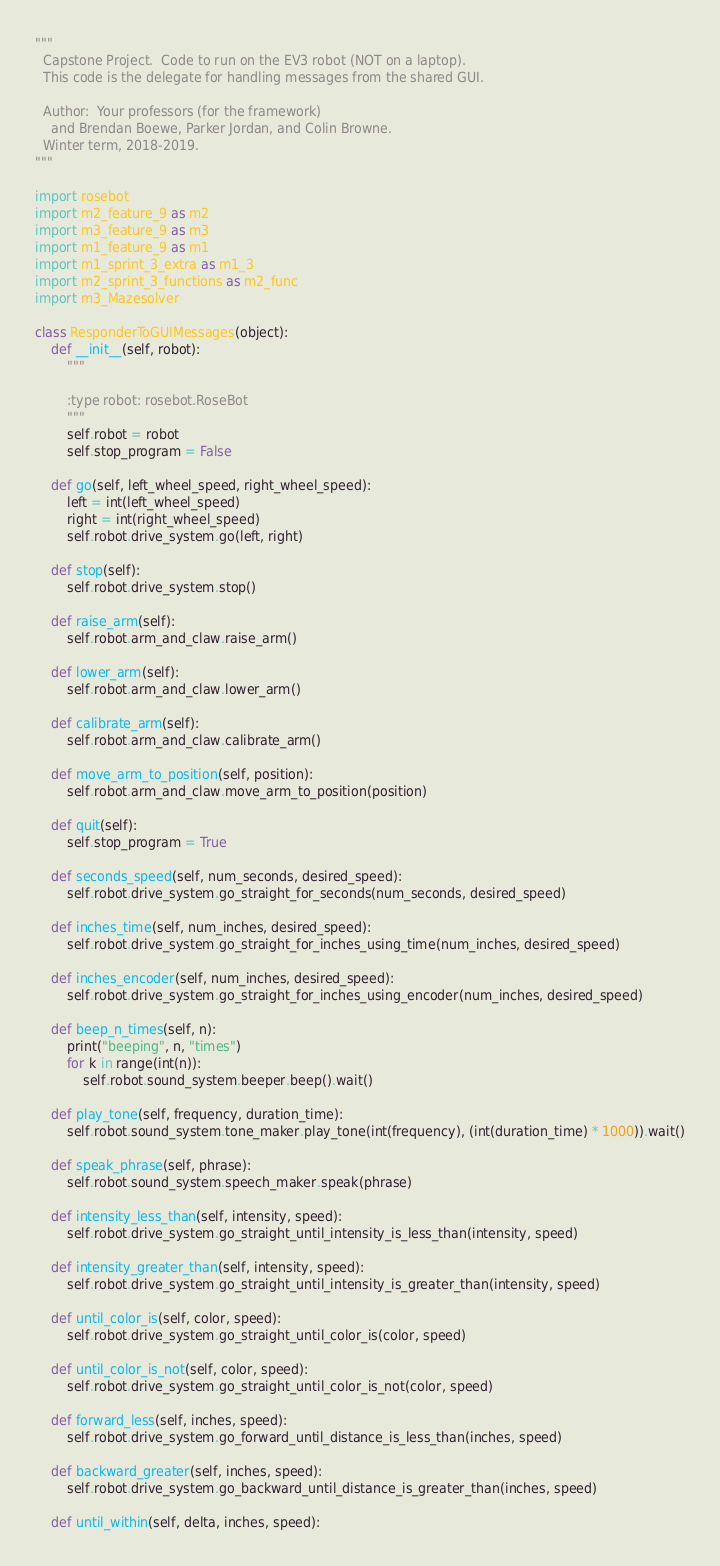Convert code to text. <code><loc_0><loc_0><loc_500><loc_500><_Python_>"""
  Capstone Project.  Code to run on the EV3 robot (NOT on a laptop).
  This code is the delegate for handling messages from the shared GUI.

  Author:  Your professors (for the framework)
    and Brendan Boewe, Parker Jordan, and Colin Browne.
  Winter term, 2018-2019.
"""

import rosebot
import m2_feature_9 as m2
import m3_feature_9 as m3
import m1_feature_9 as m1
import m1_sprint_3_extra as m1_3
import m2_sprint_3_functions as m2_func
import m3_Mazesolver

class ResponderToGUIMessages(object):
    def __init__(self, robot):
        """

        :type robot: rosebot.RoseBot
        """
        self.robot = robot
        self.stop_program = False

    def go(self, left_wheel_speed, right_wheel_speed):
        left = int(left_wheel_speed)
        right = int(right_wheel_speed)
        self.robot.drive_system.go(left, right)

    def stop(self):
        self.robot.drive_system.stop()

    def raise_arm(self):
        self.robot.arm_and_claw.raise_arm()

    def lower_arm(self):
        self.robot.arm_and_claw.lower_arm()

    def calibrate_arm(self):
        self.robot.arm_and_claw.calibrate_arm()

    def move_arm_to_position(self, position):
        self.robot.arm_and_claw.move_arm_to_position(position)

    def quit(self):
        self.stop_program = True

    def seconds_speed(self, num_seconds, desired_speed):
        self.robot.drive_system.go_straight_for_seconds(num_seconds, desired_speed)

    def inches_time(self, num_inches, desired_speed):
        self.robot.drive_system.go_straight_for_inches_using_time(num_inches, desired_speed)

    def inches_encoder(self, num_inches, desired_speed):
        self.robot.drive_system.go_straight_for_inches_using_encoder(num_inches, desired_speed)

    def beep_n_times(self, n):
        print("beeping", n, "times")
        for k in range(int(n)):
            self.robot.sound_system.beeper.beep().wait()

    def play_tone(self, frequency, duration_time):
        self.robot.sound_system.tone_maker.play_tone(int(frequency), (int(duration_time) * 1000)).wait()

    def speak_phrase(self, phrase):
        self.robot.sound_system.speech_maker.speak(phrase)

    def intensity_less_than(self, intensity, speed):
        self.robot.drive_system.go_straight_until_intensity_is_less_than(intensity, speed)

    def intensity_greater_than(self, intensity, speed):
        self.robot.drive_system.go_straight_until_intensity_is_greater_than(intensity, speed)

    def until_color_is(self, color, speed):
        self.robot.drive_system.go_straight_until_color_is(color, speed)

    def until_color_is_not(self, color, speed):
        self.robot.drive_system.go_straight_until_color_is_not(color, speed)

    def forward_less(self, inches, speed):
        self.robot.drive_system.go_forward_until_distance_is_less_than(inches, speed)

    def backward_greater(self, inches, speed):
        self.robot.drive_system.go_backward_until_distance_is_greater_than(inches, speed)

    def until_within(self, delta, inches, speed):</code> 